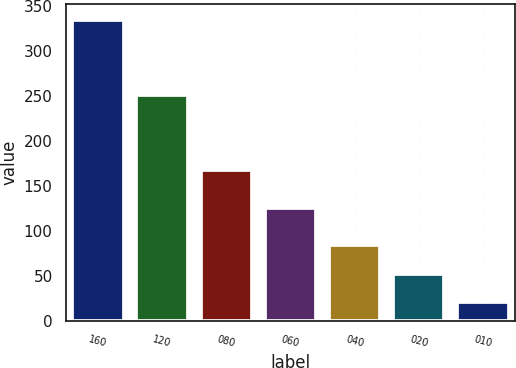Convert chart to OTSL. <chart><loc_0><loc_0><loc_500><loc_500><bar_chart><fcel>160<fcel>120<fcel>080<fcel>060<fcel>040<fcel>020<fcel>010<nl><fcel>335<fcel>251<fcel>168<fcel>126<fcel>84<fcel>52.4<fcel>21<nl></chart> 